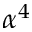Convert formula to latex. <formula><loc_0><loc_0><loc_500><loc_500>\alpha ^ { 4 }</formula> 